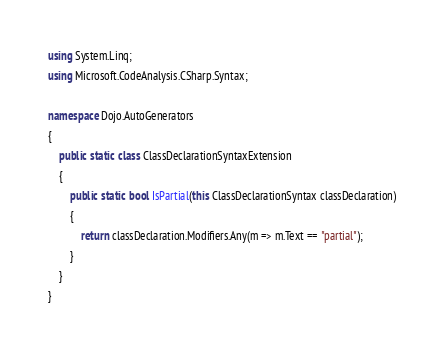<code> <loc_0><loc_0><loc_500><loc_500><_C#_>using System.Linq;
using Microsoft.CodeAnalysis.CSharp.Syntax;

namespace Dojo.AutoGenerators
{
    public static class ClassDeclarationSyntaxExtension
    {
        public static bool IsPartial(this ClassDeclarationSyntax classDeclaration)
        {
            return classDeclaration.Modifiers.Any(m => m.Text == "partial");
        }
    }
}</code> 